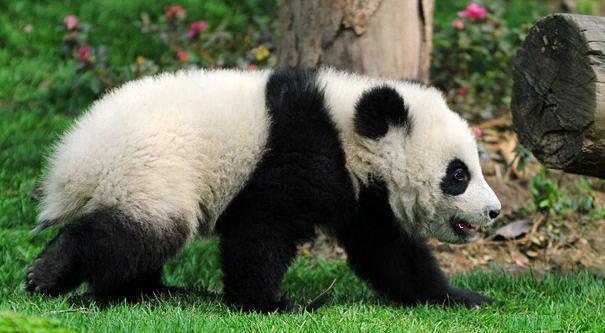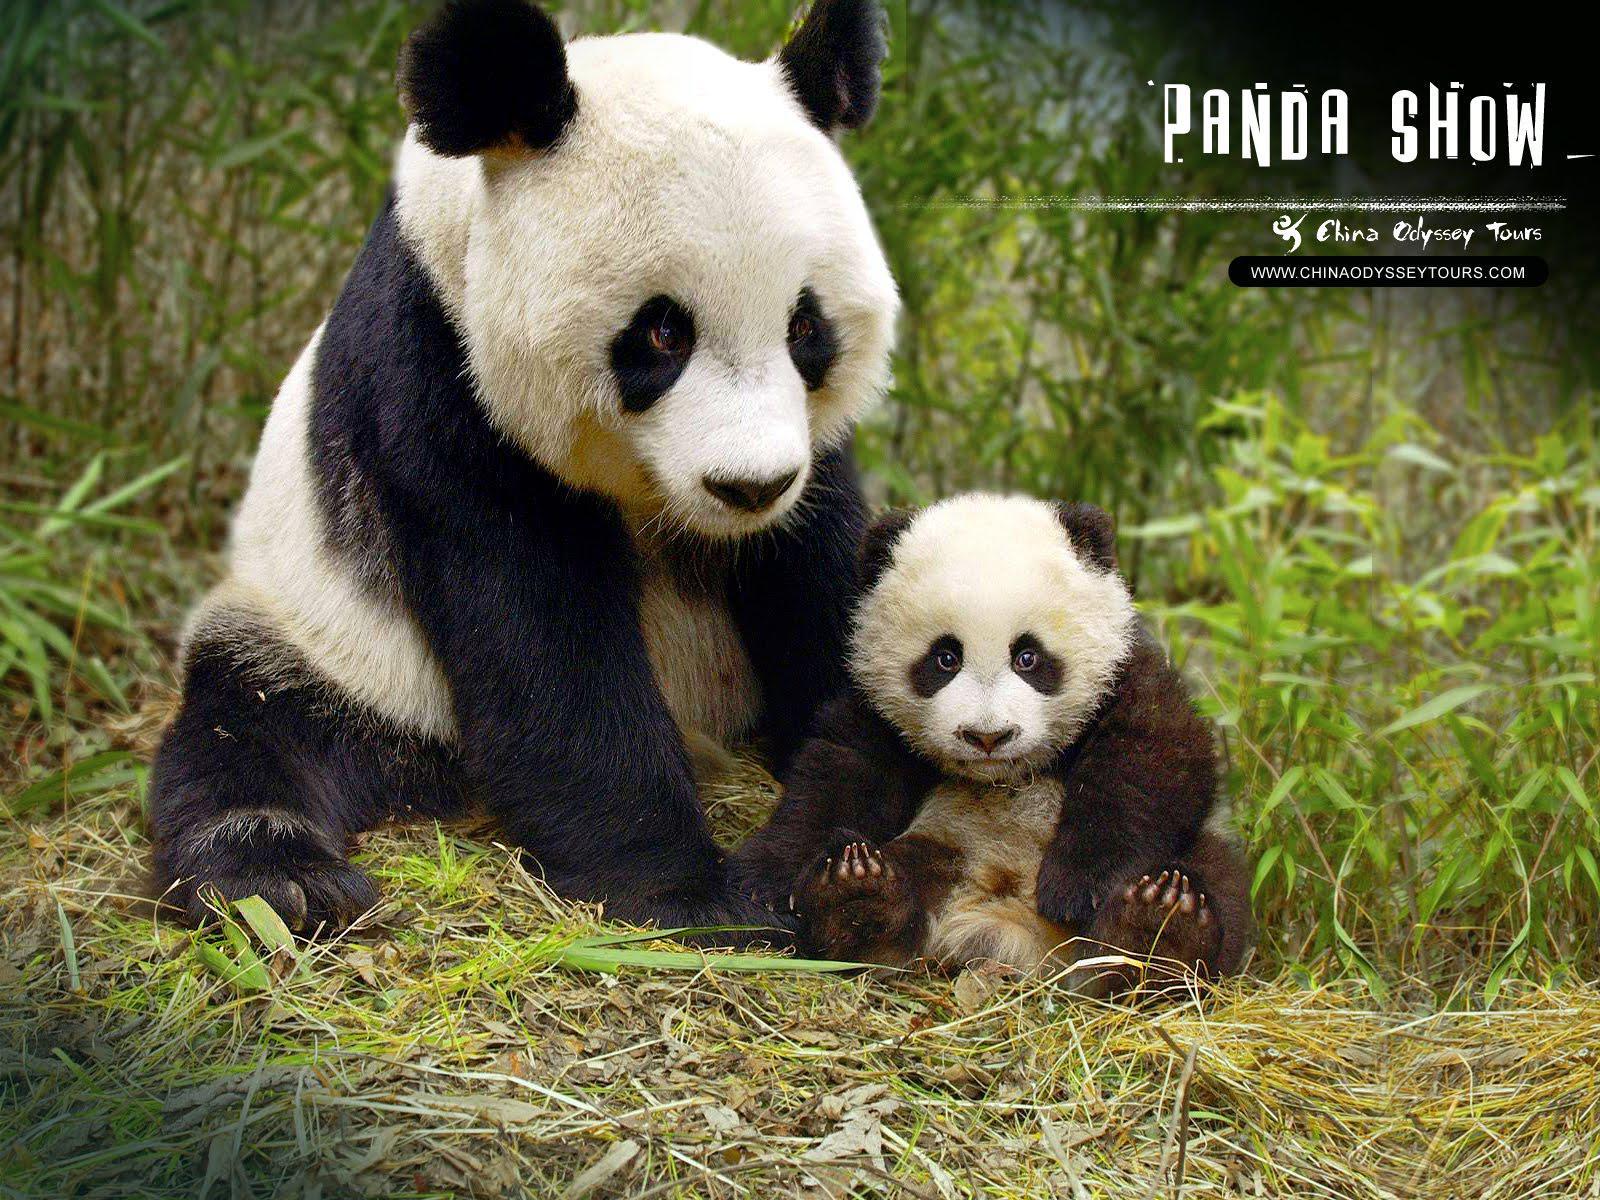The first image is the image on the left, the second image is the image on the right. Analyze the images presented: Is the assertion "In one image, an adult panda is sitting upright with a baby panda sitting beside her." valid? Answer yes or no. Yes. 